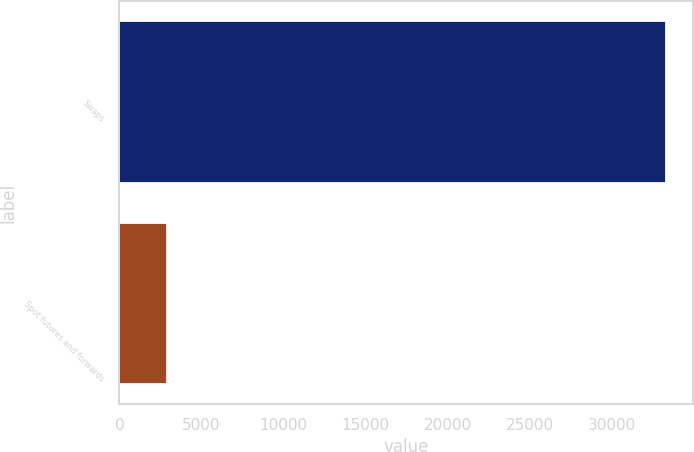Convert chart to OTSL. <chart><loc_0><loc_0><loc_500><loc_500><bar_chart><fcel>Swaps<fcel>Spot futures and forwards<nl><fcel>33272<fcel>2922.5<nl></chart> 